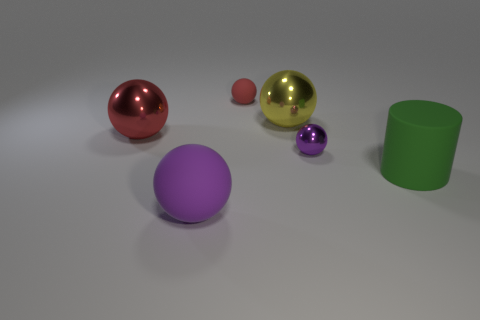Subtract all yellow balls. How many balls are left? 4 Subtract all large purple balls. How many balls are left? 4 Subtract all cyan spheres. Subtract all purple cylinders. How many spheres are left? 5 Add 2 small purple spheres. How many objects exist? 8 Subtract all spheres. How many objects are left? 1 Subtract 1 yellow spheres. How many objects are left? 5 Subtract all tiny brown matte cylinders. Subtract all red shiny things. How many objects are left? 5 Add 3 purple metal objects. How many purple metal objects are left? 4 Add 3 cyan objects. How many cyan objects exist? 3 